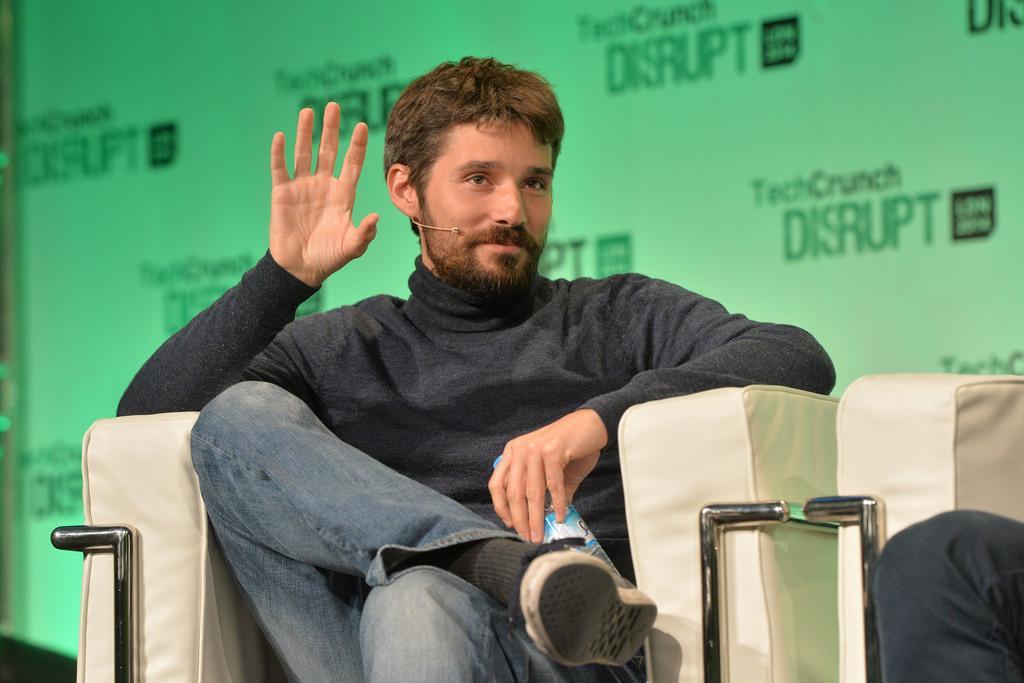Describe this image in one or two sentences. In this image I can see a person wearing black dress and blue jeans is sitting in a cream colored couch and holding a water bottle. In the background I can see the green colored surface. To the right side of the image I can see another person sitting on a couch. 